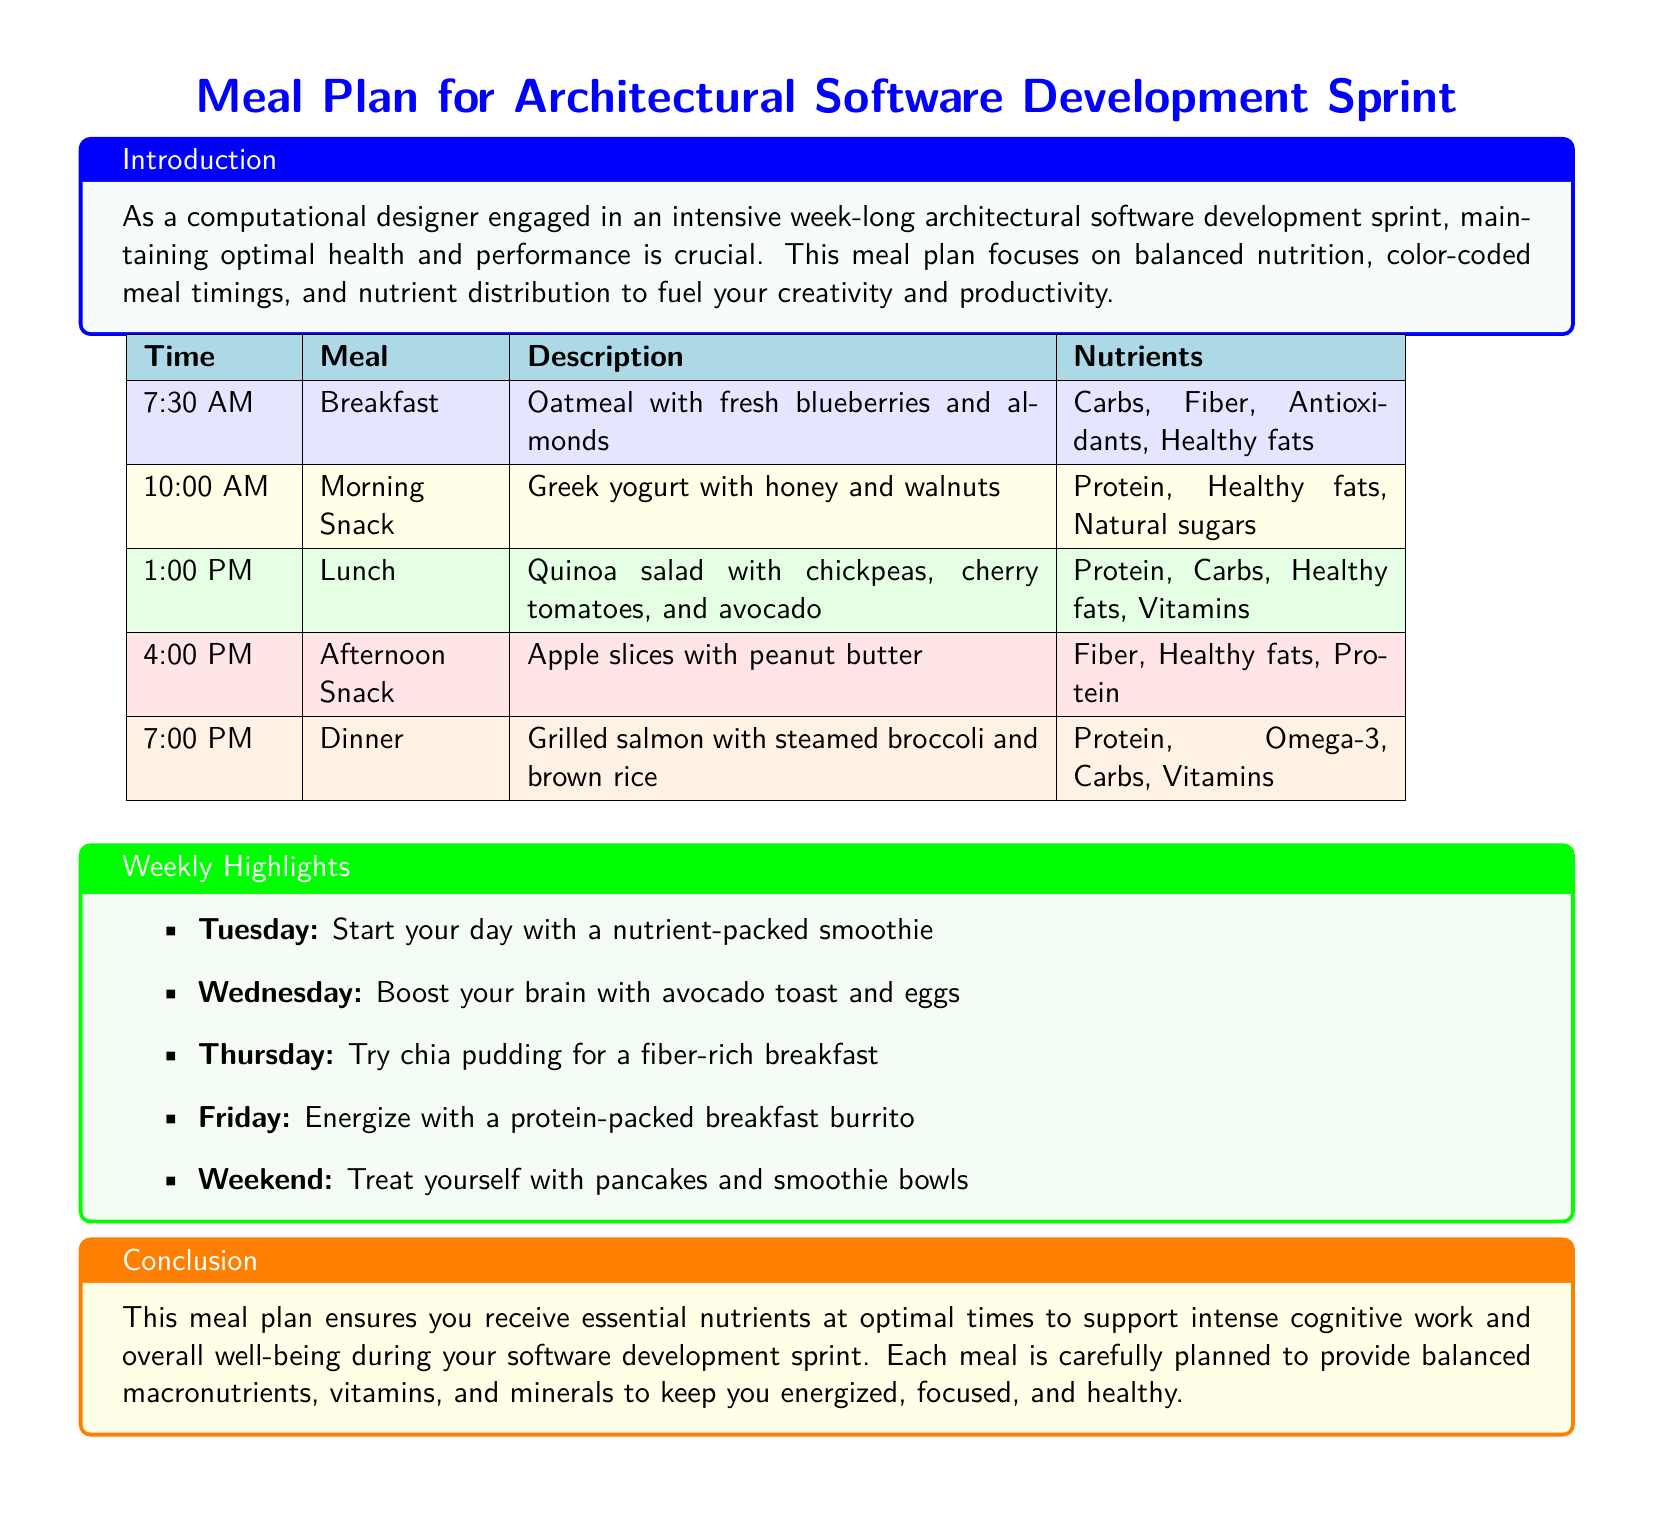What is the first meal of the day? The first meal listed in the document is breakfast, which is scheduled for 7:30 AM.
Answer: Oatmeal with fresh blueberries and almonds How many snacks are included in the meal plan? The document lists two snacks: morning and afternoon, indicating a total of two snacks.
Answer: 2 What nutrient is highlighted in the lunch meal? The lunch meal is described as including protein, carbs, healthy fats, and vitamins, thus specifically protein stands out for its importance.
Answer: Protein What time is dinner served? According to the document, dinner is scheduled for 7:00 PM.
Answer: 7:00 PM What is the main ingredient in the morning snack? The morning snack includes Greek yogurt with honey and walnuts as its main ingredients, focusing on a healthy fat source.
Answer: Greek yogurt Which day features a smoothie for breakfast? The document mentions that Tuesday features a nutrient-packed smoothie as a highlight for that day.
Answer: Tuesday What is the color coding for lunch? The document specifies a green color coding for the lunch meal.
Answer: Green What is the last meal described in the plan? The last meal mentioned in the meal plan is dinner, which is scheduled at 7:00 PM.
Answer: Dinner 